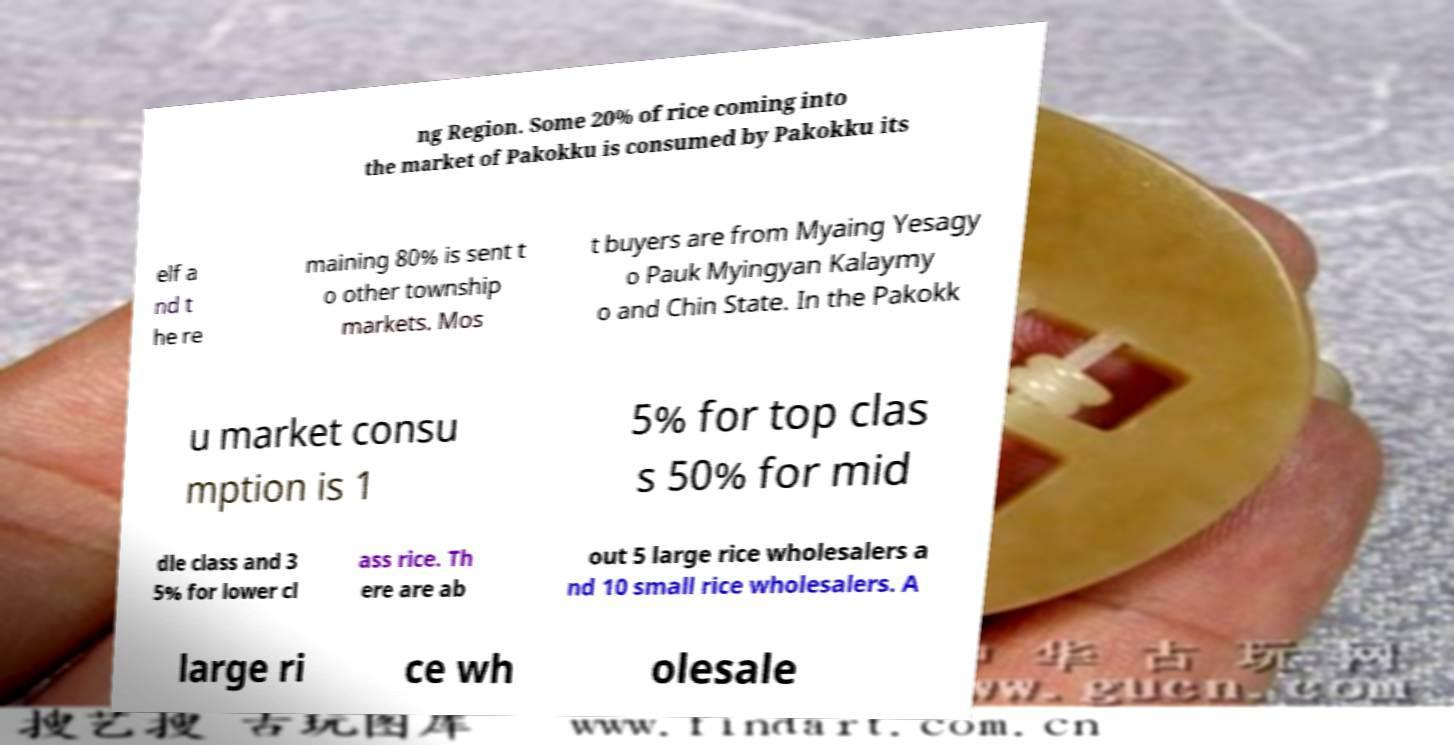Please read and relay the text visible in this image. What does it say? ng Region. Some 20% of rice coming into the market of Pakokku is consumed by Pakokku its elf a nd t he re maining 80% is sent t o other township markets. Mos t buyers are from Myaing Yesagy o Pauk Myingyan Kalaymy o and Chin State. In the Pakokk u market consu mption is 1 5% for top clas s 50% for mid dle class and 3 5% for lower cl ass rice. Th ere are ab out 5 large rice wholesalers a nd 10 small rice wholesalers. A large ri ce wh olesale 